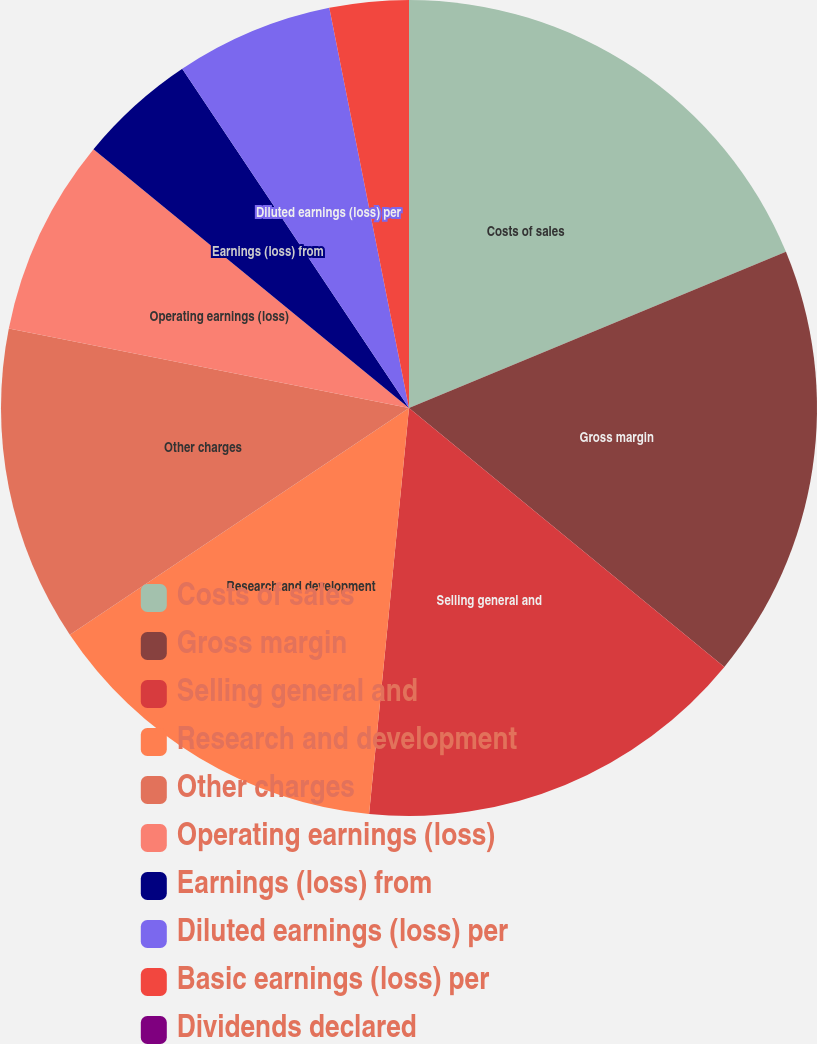Convert chart. <chart><loc_0><loc_0><loc_500><loc_500><pie_chart><fcel>Costs of sales<fcel>Gross margin<fcel>Selling general and<fcel>Research and development<fcel>Other charges<fcel>Operating earnings (loss)<fcel>Earnings (loss) from<fcel>Diluted earnings (loss) per<fcel>Basic earnings (loss) per<fcel>Dividends declared<nl><fcel>18.75%<fcel>17.19%<fcel>15.62%<fcel>14.06%<fcel>12.5%<fcel>7.81%<fcel>4.69%<fcel>6.25%<fcel>3.13%<fcel>0.0%<nl></chart> 